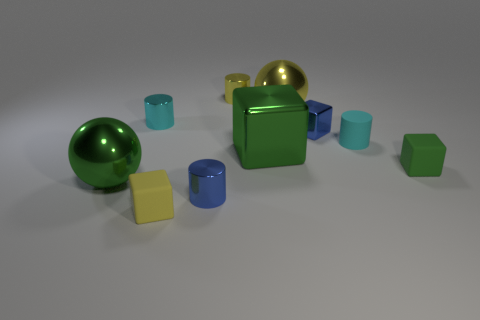Do the cyan metallic thing and the green cube that is to the left of the green rubber cube have the same size? No, the cyan metallic object appears to be a sphere and is noticeably larger than the small green cube located to the left of the slightly larger green rubber cube. 